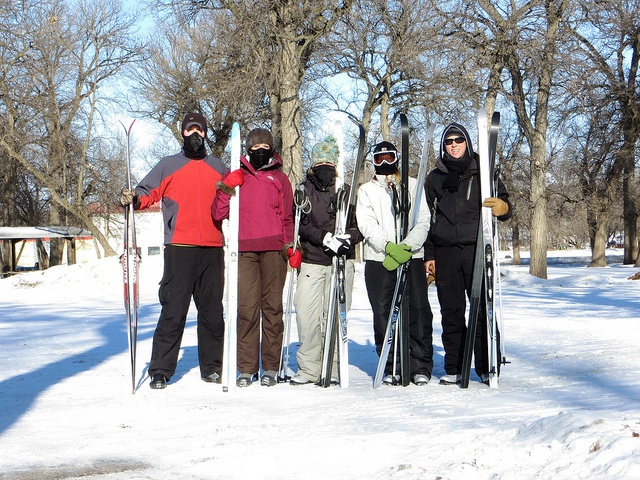Describe the objects in this image and their specific colors. I can see people in darkgray, black, red, and gray tones, people in darkgray, black, white, and gray tones, people in darkgray, black, gray, and white tones, people in darkgray, maroon, brown, and gray tones, and people in darkgray, black, lightgray, and gray tones in this image. 